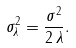<formula> <loc_0><loc_0><loc_500><loc_500>\sigma _ { \lambda } ^ { 2 } = \frac { \sigma ^ { 2 } } { 2 \, \lambda } .</formula> 